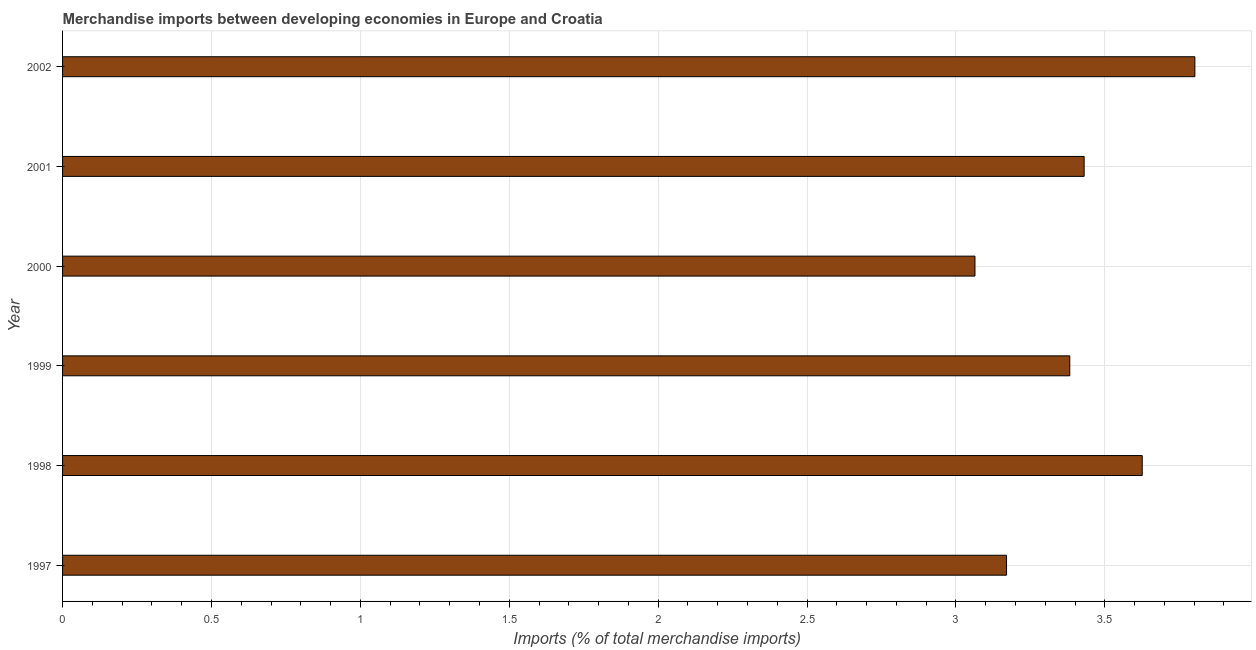Does the graph contain any zero values?
Keep it short and to the point. No. Does the graph contain grids?
Make the answer very short. Yes. What is the title of the graph?
Your answer should be compact. Merchandise imports between developing economies in Europe and Croatia. What is the label or title of the X-axis?
Make the answer very short. Imports (% of total merchandise imports). What is the label or title of the Y-axis?
Provide a short and direct response. Year. What is the merchandise imports in 1999?
Your response must be concise. 3.38. Across all years, what is the maximum merchandise imports?
Offer a terse response. 3.8. Across all years, what is the minimum merchandise imports?
Offer a terse response. 3.06. In which year was the merchandise imports maximum?
Your answer should be compact. 2002. What is the sum of the merchandise imports?
Provide a succinct answer. 20.47. What is the difference between the merchandise imports in 1997 and 2002?
Offer a terse response. -0.63. What is the average merchandise imports per year?
Provide a short and direct response. 3.41. What is the median merchandise imports?
Your response must be concise. 3.41. In how many years, is the merchandise imports greater than 2 %?
Your answer should be very brief. 6. Do a majority of the years between 2000 and 2001 (inclusive) have merchandise imports greater than 0.9 %?
Your answer should be compact. Yes. What is the ratio of the merchandise imports in 1999 to that in 2002?
Ensure brevity in your answer.  0.89. Is the merchandise imports in 1999 less than that in 2002?
Provide a short and direct response. Yes. What is the difference between the highest and the second highest merchandise imports?
Make the answer very short. 0.18. Is the sum of the merchandise imports in 1998 and 1999 greater than the maximum merchandise imports across all years?
Provide a short and direct response. Yes. What is the difference between the highest and the lowest merchandise imports?
Offer a terse response. 0.74. Are all the bars in the graph horizontal?
Provide a short and direct response. Yes. How many years are there in the graph?
Your response must be concise. 6. What is the Imports (% of total merchandise imports) in 1997?
Provide a succinct answer. 3.17. What is the Imports (% of total merchandise imports) in 1998?
Your answer should be very brief. 3.63. What is the Imports (% of total merchandise imports) of 1999?
Your answer should be compact. 3.38. What is the Imports (% of total merchandise imports) in 2000?
Keep it short and to the point. 3.06. What is the Imports (% of total merchandise imports) of 2001?
Provide a succinct answer. 3.43. What is the Imports (% of total merchandise imports) in 2002?
Offer a terse response. 3.8. What is the difference between the Imports (% of total merchandise imports) in 1997 and 1998?
Provide a short and direct response. -0.46. What is the difference between the Imports (% of total merchandise imports) in 1997 and 1999?
Offer a very short reply. -0.21. What is the difference between the Imports (% of total merchandise imports) in 1997 and 2000?
Your answer should be very brief. 0.11. What is the difference between the Imports (% of total merchandise imports) in 1997 and 2001?
Your answer should be compact. -0.26. What is the difference between the Imports (% of total merchandise imports) in 1997 and 2002?
Give a very brief answer. -0.63. What is the difference between the Imports (% of total merchandise imports) in 1998 and 1999?
Your answer should be very brief. 0.24. What is the difference between the Imports (% of total merchandise imports) in 1998 and 2000?
Provide a short and direct response. 0.56. What is the difference between the Imports (% of total merchandise imports) in 1998 and 2001?
Offer a terse response. 0.2. What is the difference between the Imports (% of total merchandise imports) in 1998 and 2002?
Your answer should be very brief. -0.18. What is the difference between the Imports (% of total merchandise imports) in 1999 and 2000?
Provide a short and direct response. 0.32. What is the difference between the Imports (% of total merchandise imports) in 1999 and 2001?
Ensure brevity in your answer.  -0.05. What is the difference between the Imports (% of total merchandise imports) in 1999 and 2002?
Provide a short and direct response. -0.42. What is the difference between the Imports (% of total merchandise imports) in 2000 and 2001?
Make the answer very short. -0.37. What is the difference between the Imports (% of total merchandise imports) in 2000 and 2002?
Provide a short and direct response. -0.74. What is the difference between the Imports (% of total merchandise imports) in 2001 and 2002?
Offer a very short reply. -0.37. What is the ratio of the Imports (% of total merchandise imports) in 1997 to that in 1998?
Your answer should be compact. 0.87. What is the ratio of the Imports (% of total merchandise imports) in 1997 to that in 1999?
Provide a short and direct response. 0.94. What is the ratio of the Imports (% of total merchandise imports) in 1997 to that in 2000?
Your answer should be compact. 1.03. What is the ratio of the Imports (% of total merchandise imports) in 1997 to that in 2001?
Your response must be concise. 0.92. What is the ratio of the Imports (% of total merchandise imports) in 1997 to that in 2002?
Make the answer very short. 0.83. What is the ratio of the Imports (% of total merchandise imports) in 1998 to that in 1999?
Your answer should be compact. 1.07. What is the ratio of the Imports (% of total merchandise imports) in 1998 to that in 2000?
Keep it short and to the point. 1.18. What is the ratio of the Imports (% of total merchandise imports) in 1998 to that in 2001?
Ensure brevity in your answer.  1.06. What is the ratio of the Imports (% of total merchandise imports) in 1998 to that in 2002?
Your response must be concise. 0.95. What is the ratio of the Imports (% of total merchandise imports) in 1999 to that in 2000?
Your answer should be compact. 1.1. What is the ratio of the Imports (% of total merchandise imports) in 1999 to that in 2001?
Ensure brevity in your answer.  0.99. What is the ratio of the Imports (% of total merchandise imports) in 1999 to that in 2002?
Provide a succinct answer. 0.89. What is the ratio of the Imports (% of total merchandise imports) in 2000 to that in 2001?
Your response must be concise. 0.89. What is the ratio of the Imports (% of total merchandise imports) in 2000 to that in 2002?
Make the answer very short. 0.81. What is the ratio of the Imports (% of total merchandise imports) in 2001 to that in 2002?
Make the answer very short. 0.9. 